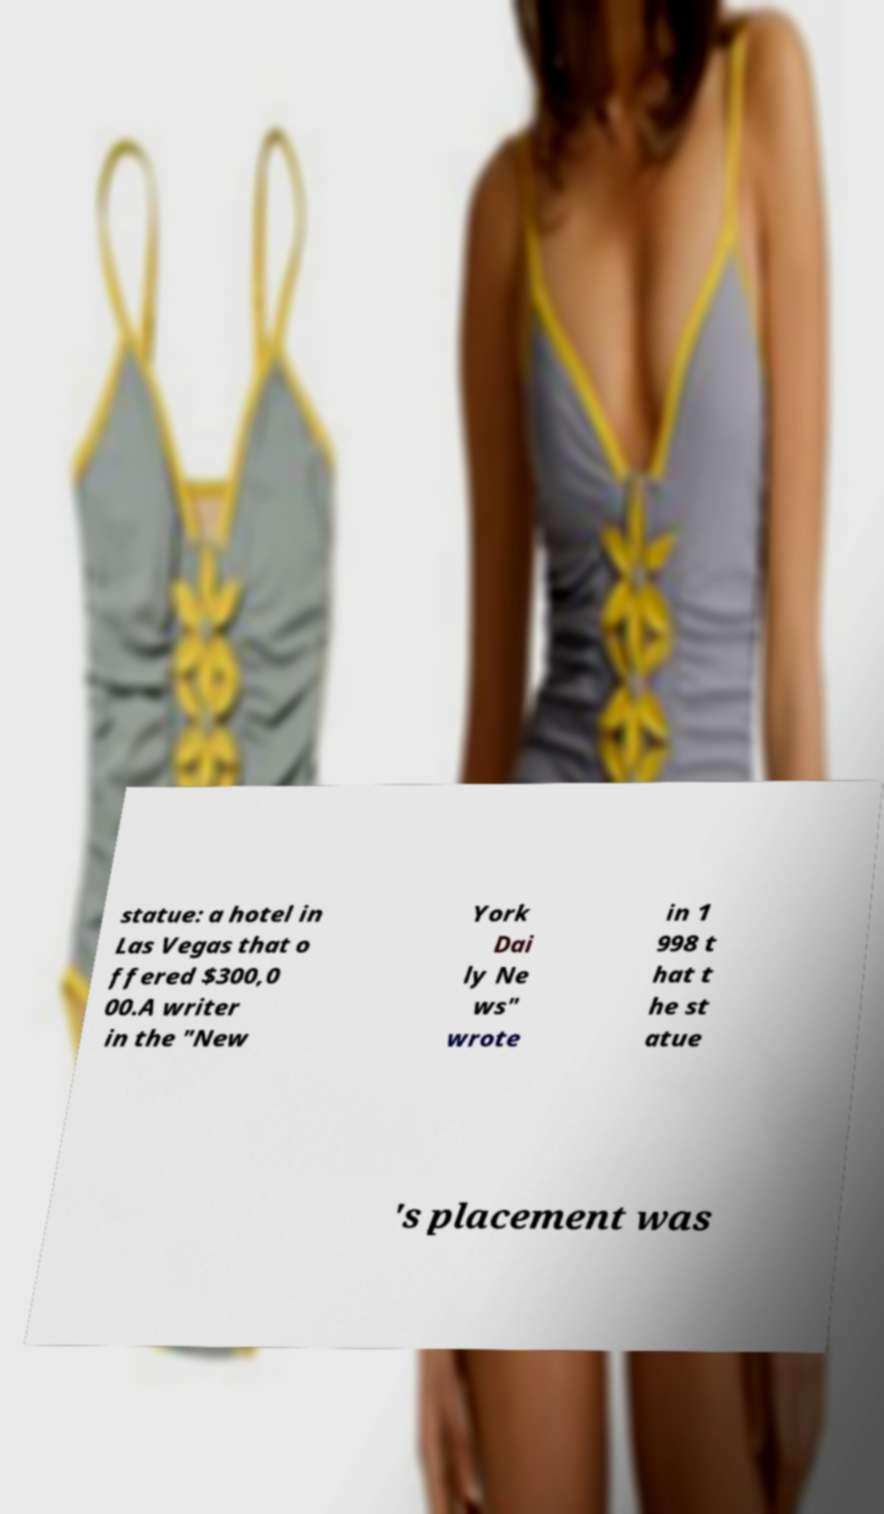For documentation purposes, I need the text within this image transcribed. Could you provide that? statue: a hotel in Las Vegas that o ffered $300,0 00.A writer in the "New York Dai ly Ne ws" wrote in 1 998 t hat t he st atue 's placement was 